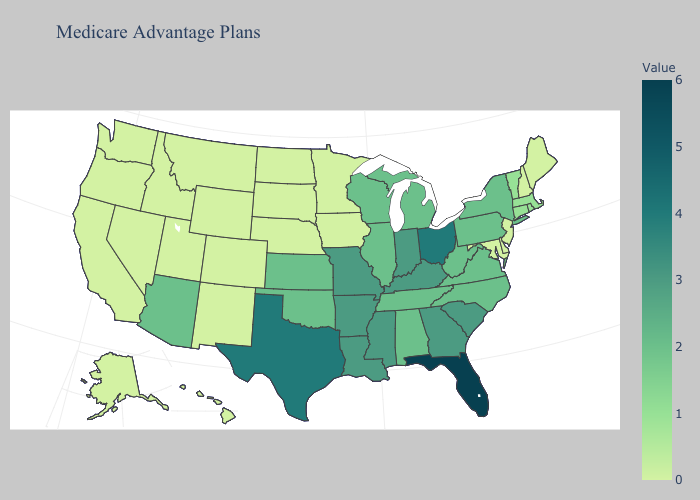Does North Carolina have the lowest value in the USA?
Keep it brief. No. Which states have the highest value in the USA?
Keep it brief. Florida. Among the states that border Virginia , does Kentucky have the highest value?
Answer briefly. Yes. Among the states that border Arizona , which have the highest value?
Write a very short answer. California, Colorado, New Mexico, Nevada, Utah. Does the map have missing data?
Keep it brief. No. 